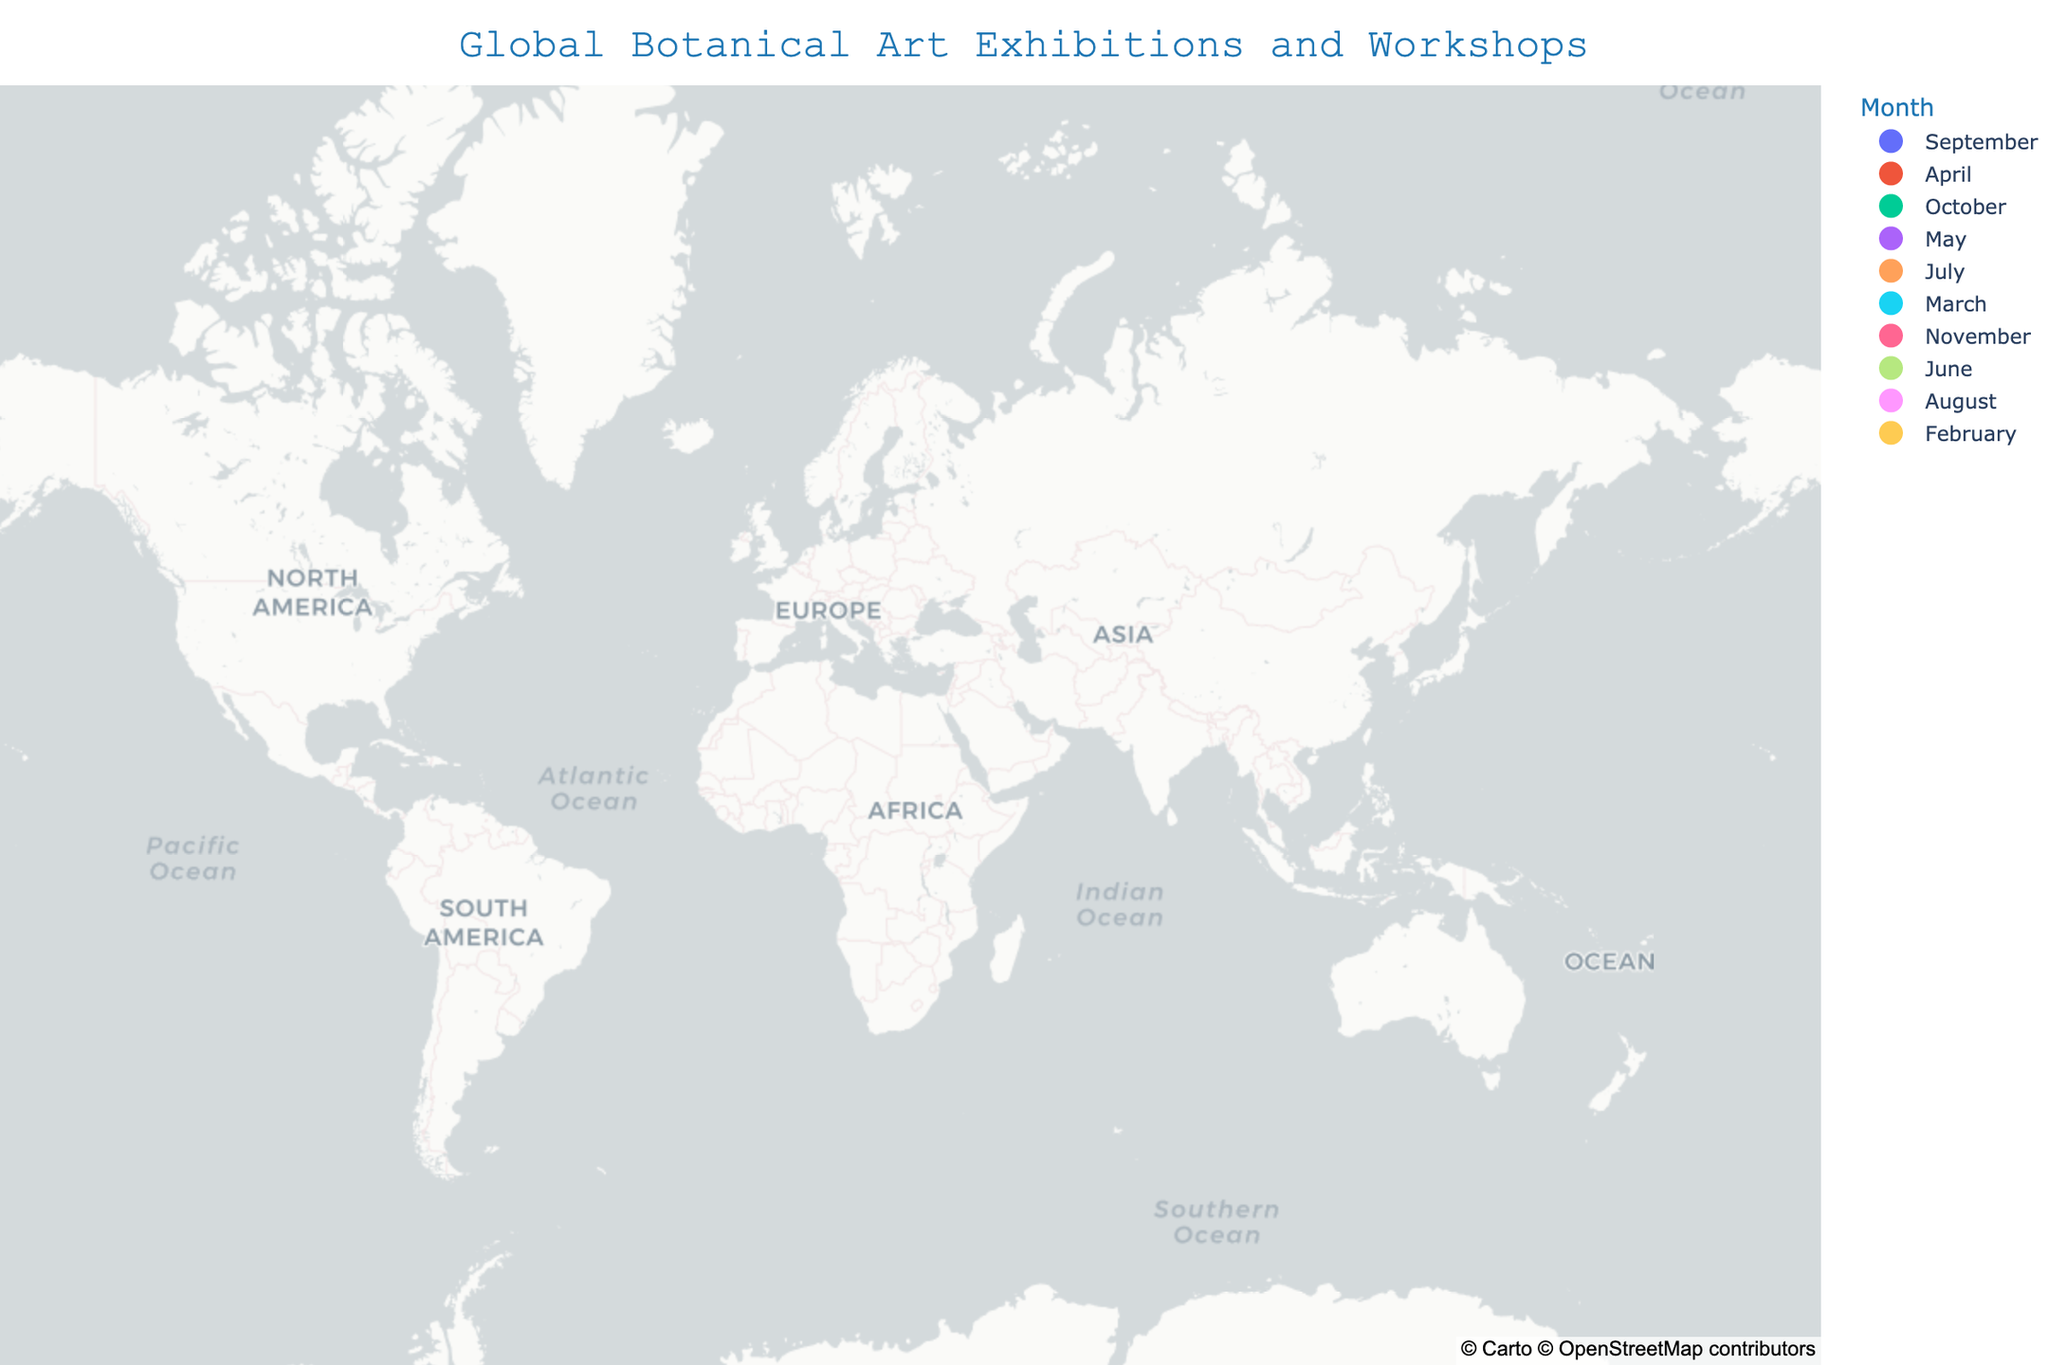What is the title of the figure? The title is typically located at the top of the figure. It provides an overview of the subject depicted in the figure. The title here is "Global Botanical Art Exhibitions and Workshops".
Answer: Global Botanical Art Exhibitions and Workshops How many events occur in Europe? Europe includes locations like London, Kew Gardens, Edinburgh, and Munich. By counting these points, which all fall within Europe, we can determine the number of events.
Answer: 4 Which event is held in September? By looking at the hover information or legend associated with the month, we can locate the event happening in September. It is associated with New York.
Answer: American Society of Botanical Artists Annual Conference What is the southernmost location where an event is held? The latitude indicates the north-south position; the smallest latitude represents the southernmost point. Melbourne has the smallest latitude value of -37.8136 among the listed locations.
Answer: Melbourne What events occur in the Southern Hemisphere? The Southern Hemisphere has negative latitudes. Check the corresponding events for locations with negative latitudes: Melbourne and Cape Town.
Answer: Botanical Art Society of Australia Exhibition and Botanical Art Worldwide Exhibition Which event occurs closest to Greenwich Meridian? The Greenwich Meridian is at longitude 0.0. By examining the longitudes, London (-0.1278) and Kew Gardens (-0.2956) are close to the meridian, but London is closest.
Answer: RHS Botanical Art Show How many events take place in the month of May? By referring to the legend or hover details, identify which events are marked for May. The Kew Gardens Botanical Art Festival occurs in May.
Answer: 1 Which event occurs at the highest latitude? The highest latitude corresponds to the northernmost point. Edinburgh, with a latitude of 55.9533, is the northernmost location on the list.
Answer: Royal Botanic Garden Edinburgh Art Workshop Compare the number of events in North America and Asia. Which continent has more events? North America includes New York and Montreal, and Asia includes Tokyo and Singapore. Count the events in each and compare. Both have 2 events each.
Answer: Both have the same number What is the longitude range of the events depicted in the plot? The longitude range can be found by identifying the minimum and maximum longitude values from the dataset. The smallest is -74.0060 (New York) and the largest is 144.9631 (Melbourne). The range is from -74.0060 to 144.9631.
Answer: -74.0060 to 144.9631 